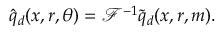Convert formula to latex. <formula><loc_0><loc_0><loc_500><loc_500>\hat { q } _ { d } ( x , r , \theta ) = \mathcal { F } ^ { - 1 } \tilde { q } _ { d } ( x , r , m ) .</formula> 